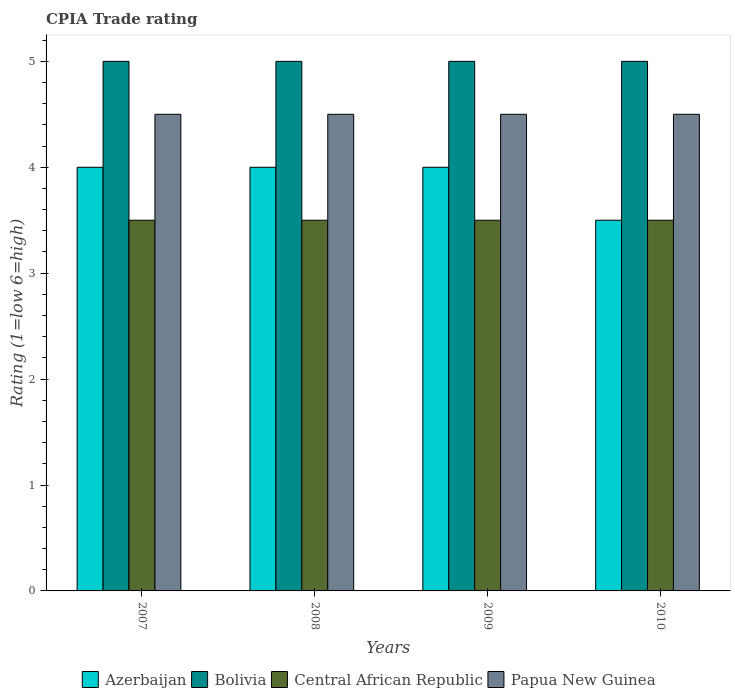How many different coloured bars are there?
Provide a short and direct response. 4. Are the number of bars per tick equal to the number of legend labels?
Provide a short and direct response. Yes. Are the number of bars on each tick of the X-axis equal?
Offer a terse response. Yes. How many bars are there on the 2nd tick from the left?
Offer a terse response. 4. How many bars are there on the 1st tick from the right?
Provide a short and direct response. 4. In how many cases, is the number of bars for a given year not equal to the number of legend labels?
Your answer should be very brief. 0. What is the CPIA rating in Papua New Guinea in 2007?
Give a very brief answer. 4.5. Across all years, what is the minimum CPIA rating in Bolivia?
Your answer should be compact. 5. In which year was the CPIA rating in Azerbaijan maximum?
Your response must be concise. 2007. In which year was the CPIA rating in Central African Republic minimum?
Make the answer very short. 2007. What is the difference between the CPIA rating in Papua New Guinea in 2007 and that in 2008?
Give a very brief answer. 0. What is the difference between the CPIA rating in Bolivia in 2007 and the CPIA rating in Azerbaijan in 2010?
Keep it short and to the point. 1.5. What is the ratio of the CPIA rating in Azerbaijan in 2007 to that in 2009?
Provide a succinct answer. 1. Is the CPIA rating in Papua New Guinea in 2008 less than that in 2009?
Offer a terse response. No. What is the difference between the highest and the second highest CPIA rating in Papua New Guinea?
Your answer should be compact. 0. In how many years, is the CPIA rating in Central African Republic greater than the average CPIA rating in Central African Republic taken over all years?
Make the answer very short. 0. Is the sum of the CPIA rating in Central African Republic in 2008 and 2010 greater than the maximum CPIA rating in Azerbaijan across all years?
Your answer should be compact. Yes. What does the 2nd bar from the left in 2007 represents?
Your answer should be very brief. Bolivia. What does the 2nd bar from the right in 2010 represents?
Provide a short and direct response. Central African Republic. How many bars are there?
Provide a short and direct response. 16. How many years are there in the graph?
Offer a terse response. 4. What is the difference between two consecutive major ticks on the Y-axis?
Your answer should be compact. 1. Are the values on the major ticks of Y-axis written in scientific E-notation?
Your response must be concise. No. Does the graph contain any zero values?
Your response must be concise. No. Does the graph contain grids?
Provide a short and direct response. No. How are the legend labels stacked?
Offer a very short reply. Horizontal. What is the title of the graph?
Ensure brevity in your answer.  CPIA Trade rating. Does "Cameroon" appear as one of the legend labels in the graph?
Keep it short and to the point. No. What is the Rating (1=low 6=high) of Azerbaijan in 2007?
Keep it short and to the point. 4. What is the Rating (1=low 6=high) in Bolivia in 2007?
Offer a terse response. 5. What is the Rating (1=low 6=high) in Papua New Guinea in 2008?
Provide a short and direct response. 4.5. What is the Rating (1=low 6=high) in Azerbaijan in 2009?
Provide a succinct answer. 4. What is the Rating (1=low 6=high) in Bolivia in 2009?
Give a very brief answer. 5. What is the Rating (1=low 6=high) in Central African Republic in 2009?
Provide a succinct answer. 3.5. What is the Rating (1=low 6=high) in Papua New Guinea in 2009?
Your answer should be compact. 4.5. What is the Rating (1=low 6=high) of Azerbaijan in 2010?
Make the answer very short. 3.5. What is the Rating (1=low 6=high) of Papua New Guinea in 2010?
Your answer should be very brief. 4.5. Across all years, what is the maximum Rating (1=low 6=high) in Bolivia?
Provide a short and direct response. 5. Across all years, what is the maximum Rating (1=low 6=high) in Central African Republic?
Your answer should be compact. 3.5. Across all years, what is the maximum Rating (1=low 6=high) of Papua New Guinea?
Your answer should be very brief. 4.5. Across all years, what is the minimum Rating (1=low 6=high) of Azerbaijan?
Give a very brief answer. 3.5. Across all years, what is the minimum Rating (1=low 6=high) in Bolivia?
Give a very brief answer. 5. Across all years, what is the minimum Rating (1=low 6=high) of Papua New Guinea?
Offer a terse response. 4.5. What is the difference between the Rating (1=low 6=high) of Bolivia in 2007 and that in 2008?
Provide a short and direct response. 0. What is the difference between the Rating (1=low 6=high) of Azerbaijan in 2007 and that in 2009?
Offer a very short reply. 0. What is the difference between the Rating (1=low 6=high) in Central African Republic in 2007 and that in 2009?
Ensure brevity in your answer.  0. What is the difference between the Rating (1=low 6=high) of Papua New Guinea in 2007 and that in 2009?
Ensure brevity in your answer.  0. What is the difference between the Rating (1=low 6=high) in Papua New Guinea in 2008 and that in 2009?
Give a very brief answer. 0. What is the difference between the Rating (1=low 6=high) in Azerbaijan in 2008 and that in 2010?
Your response must be concise. 0.5. What is the difference between the Rating (1=low 6=high) of Central African Republic in 2008 and that in 2010?
Make the answer very short. 0. What is the difference between the Rating (1=low 6=high) of Azerbaijan in 2009 and that in 2010?
Keep it short and to the point. 0.5. What is the difference between the Rating (1=low 6=high) of Central African Republic in 2009 and that in 2010?
Provide a succinct answer. 0. What is the difference between the Rating (1=low 6=high) of Bolivia in 2007 and the Rating (1=low 6=high) of Papua New Guinea in 2008?
Make the answer very short. 0.5. What is the difference between the Rating (1=low 6=high) of Azerbaijan in 2007 and the Rating (1=low 6=high) of Bolivia in 2009?
Provide a succinct answer. -1. What is the difference between the Rating (1=low 6=high) of Azerbaijan in 2007 and the Rating (1=low 6=high) of Papua New Guinea in 2009?
Provide a short and direct response. -0.5. What is the difference between the Rating (1=low 6=high) of Bolivia in 2007 and the Rating (1=low 6=high) of Central African Republic in 2009?
Offer a terse response. 1.5. What is the difference between the Rating (1=low 6=high) in Bolivia in 2007 and the Rating (1=low 6=high) in Papua New Guinea in 2009?
Your answer should be very brief. 0.5. What is the difference between the Rating (1=low 6=high) of Central African Republic in 2007 and the Rating (1=low 6=high) of Papua New Guinea in 2009?
Make the answer very short. -1. What is the difference between the Rating (1=low 6=high) of Azerbaijan in 2007 and the Rating (1=low 6=high) of Bolivia in 2010?
Give a very brief answer. -1. What is the difference between the Rating (1=low 6=high) of Azerbaijan in 2007 and the Rating (1=low 6=high) of Papua New Guinea in 2010?
Give a very brief answer. -0.5. What is the difference between the Rating (1=low 6=high) in Bolivia in 2007 and the Rating (1=low 6=high) in Papua New Guinea in 2010?
Ensure brevity in your answer.  0.5. What is the difference between the Rating (1=low 6=high) of Azerbaijan in 2008 and the Rating (1=low 6=high) of Bolivia in 2009?
Your response must be concise. -1. What is the difference between the Rating (1=low 6=high) of Azerbaijan in 2008 and the Rating (1=low 6=high) of Papua New Guinea in 2009?
Your answer should be very brief. -0.5. What is the difference between the Rating (1=low 6=high) in Bolivia in 2008 and the Rating (1=low 6=high) in Central African Republic in 2009?
Give a very brief answer. 1.5. What is the difference between the Rating (1=low 6=high) of Bolivia in 2008 and the Rating (1=low 6=high) of Papua New Guinea in 2009?
Your response must be concise. 0.5. What is the difference between the Rating (1=low 6=high) in Central African Republic in 2008 and the Rating (1=low 6=high) in Papua New Guinea in 2009?
Your response must be concise. -1. What is the difference between the Rating (1=low 6=high) of Central African Republic in 2008 and the Rating (1=low 6=high) of Papua New Guinea in 2010?
Provide a short and direct response. -1. What is the difference between the Rating (1=low 6=high) of Azerbaijan in 2009 and the Rating (1=low 6=high) of Bolivia in 2010?
Offer a terse response. -1. What is the difference between the Rating (1=low 6=high) in Bolivia in 2009 and the Rating (1=low 6=high) in Central African Republic in 2010?
Provide a succinct answer. 1.5. What is the difference between the Rating (1=low 6=high) in Bolivia in 2009 and the Rating (1=low 6=high) in Papua New Guinea in 2010?
Provide a succinct answer. 0.5. What is the difference between the Rating (1=low 6=high) in Central African Republic in 2009 and the Rating (1=low 6=high) in Papua New Guinea in 2010?
Your answer should be compact. -1. What is the average Rating (1=low 6=high) in Azerbaijan per year?
Your answer should be compact. 3.88. What is the average Rating (1=low 6=high) of Bolivia per year?
Ensure brevity in your answer.  5. What is the average Rating (1=low 6=high) of Central African Republic per year?
Offer a terse response. 3.5. What is the average Rating (1=low 6=high) in Papua New Guinea per year?
Keep it short and to the point. 4.5. In the year 2007, what is the difference between the Rating (1=low 6=high) of Azerbaijan and Rating (1=low 6=high) of Papua New Guinea?
Ensure brevity in your answer.  -0.5. In the year 2007, what is the difference between the Rating (1=low 6=high) of Bolivia and Rating (1=low 6=high) of Central African Republic?
Provide a succinct answer. 1.5. In the year 2008, what is the difference between the Rating (1=low 6=high) in Azerbaijan and Rating (1=low 6=high) in Bolivia?
Ensure brevity in your answer.  -1. In the year 2008, what is the difference between the Rating (1=low 6=high) in Azerbaijan and Rating (1=low 6=high) in Papua New Guinea?
Give a very brief answer. -0.5. In the year 2009, what is the difference between the Rating (1=low 6=high) of Azerbaijan and Rating (1=low 6=high) of Bolivia?
Your answer should be compact. -1. In the year 2009, what is the difference between the Rating (1=low 6=high) in Azerbaijan and Rating (1=low 6=high) in Papua New Guinea?
Offer a very short reply. -0.5. In the year 2009, what is the difference between the Rating (1=low 6=high) of Bolivia and Rating (1=low 6=high) of Central African Republic?
Your answer should be very brief. 1.5. In the year 2009, what is the difference between the Rating (1=low 6=high) in Bolivia and Rating (1=low 6=high) in Papua New Guinea?
Your response must be concise. 0.5. In the year 2009, what is the difference between the Rating (1=low 6=high) of Central African Republic and Rating (1=low 6=high) of Papua New Guinea?
Offer a terse response. -1. In the year 2010, what is the difference between the Rating (1=low 6=high) in Bolivia and Rating (1=low 6=high) in Central African Republic?
Offer a terse response. 1.5. In the year 2010, what is the difference between the Rating (1=low 6=high) in Bolivia and Rating (1=low 6=high) in Papua New Guinea?
Keep it short and to the point. 0.5. What is the ratio of the Rating (1=low 6=high) of Central African Republic in 2007 to that in 2008?
Give a very brief answer. 1. What is the ratio of the Rating (1=low 6=high) in Azerbaijan in 2007 to that in 2009?
Ensure brevity in your answer.  1. What is the ratio of the Rating (1=low 6=high) in Bolivia in 2007 to that in 2009?
Give a very brief answer. 1. What is the ratio of the Rating (1=low 6=high) in Papua New Guinea in 2007 to that in 2009?
Offer a very short reply. 1. What is the ratio of the Rating (1=low 6=high) in Central African Republic in 2007 to that in 2010?
Ensure brevity in your answer.  1. What is the ratio of the Rating (1=low 6=high) in Azerbaijan in 2008 to that in 2009?
Provide a succinct answer. 1. What is the ratio of the Rating (1=low 6=high) in Bolivia in 2008 to that in 2009?
Your response must be concise. 1. What is the ratio of the Rating (1=low 6=high) in Papua New Guinea in 2008 to that in 2009?
Your answer should be very brief. 1. What is the ratio of the Rating (1=low 6=high) in Papua New Guinea in 2008 to that in 2010?
Give a very brief answer. 1. What is the ratio of the Rating (1=low 6=high) of Bolivia in 2009 to that in 2010?
Your response must be concise. 1. What is the ratio of the Rating (1=low 6=high) in Central African Republic in 2009 to that in 2010?
Give a very brief answer. 1. What is the difference between the highest and the second highest Rating (1=low 6=high) in Azerbaijan?
Your answer should be compact. 0. What is the difference between the highest and the second highest Rating (1=low 6=high) in Bolivia?
Ensure brevity in your answer.  0. What is the difference between the highest and the lowest Rating (1=low 6=high) of Azerbaijan?
Keep it short and to the point. 0.5. What is the difference between the highest and the lowest Rating (1=low 6=high) in Bolivia?
Ensure brevity in your answer.  0. 